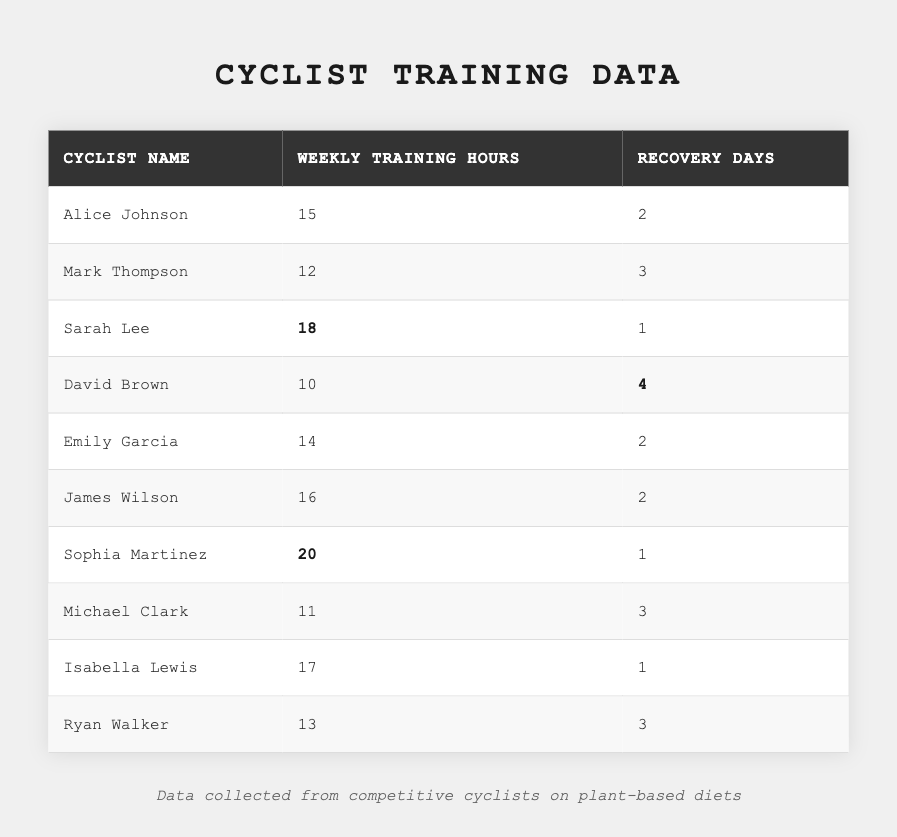What is the maximum number of weekly training hours recorded? By examining the "Weekly Training Hours" column, the highest value listed is for Sophia Martinez at 20 hours.
Answer: 20 Which cyclist has the least recovery days? Looking at the "Recovery Days" column, the minimum number of recovery days is 1, noted for both Sarah Lee, Sophia Martinez, and Isabella Lewis.
Answer: 1 How many cyclists have recovery days equal to or greater than 3? The cyclists with 3 or more recovery days are Mark Thompson, David Brown, Michael Clark, and Ryan Walker (4 in total).
Answer: 4 What is the average weekly training hours among the cyclists? Summing the weekly training hours (15 + 12 + 18 + 10 + 14 + 16 + 20 + 11 + 17 + 13 =  156), and then dividing by the number of cyclists (10), gives us an average of 156 / 10 = 15.6 hours.
Answer: 15.6 Is there a cyclist who trained for more than 15 hours while having exactly 2 recovery days? Both Alice Johnson and James Wilson trained for 15 and 16 hours with 2 recovery days, thus answering yes to this question.
Answer: Yes Which cyclist had the highest training hours and how many recovery days did they take? Sophia Martinez had the highest training hours at 20, and she took 1 recovery day.
Answer: 1 Calculate the total number of recovery days for all cyclists combined. Adding the recovery days (2 + 3 + 1 + 4 + 2 + 2 + 1 + 3 + 1 + 3 = 22) gives a total of 22 recovery days for all cyclists.
Answer: 22 What proportion of cyclists train for 15 hours or more? There are 6 cyclists who train for 15 hours or more (Alice Johnson, Sarah Lee, James Wilson, Sophia Martinez, Isabella Lewis, and Ryan Walker) out of 10 total, giving a proportion of 6/10 = 0.6.
Answer: 0.6 Which cyclist has the highest difference between weekly training hours and recovery days? For Sophia Martinez, the difference is 20 - 1 = 19. For David Brown, the difference is 10 - 4 = 6. Hence, the highest difference is from Sophia Martinez with 19.
Answer: 19 Are there any cyclists who train for 13 hours or less and take 3 or more recovery days? Only Mark Thompson (12 hours, 3 recovery days) and David Brown (10 hours, 4 recovery days) fit this criteria; therefore, the answer is yes.
Answer: Yes 